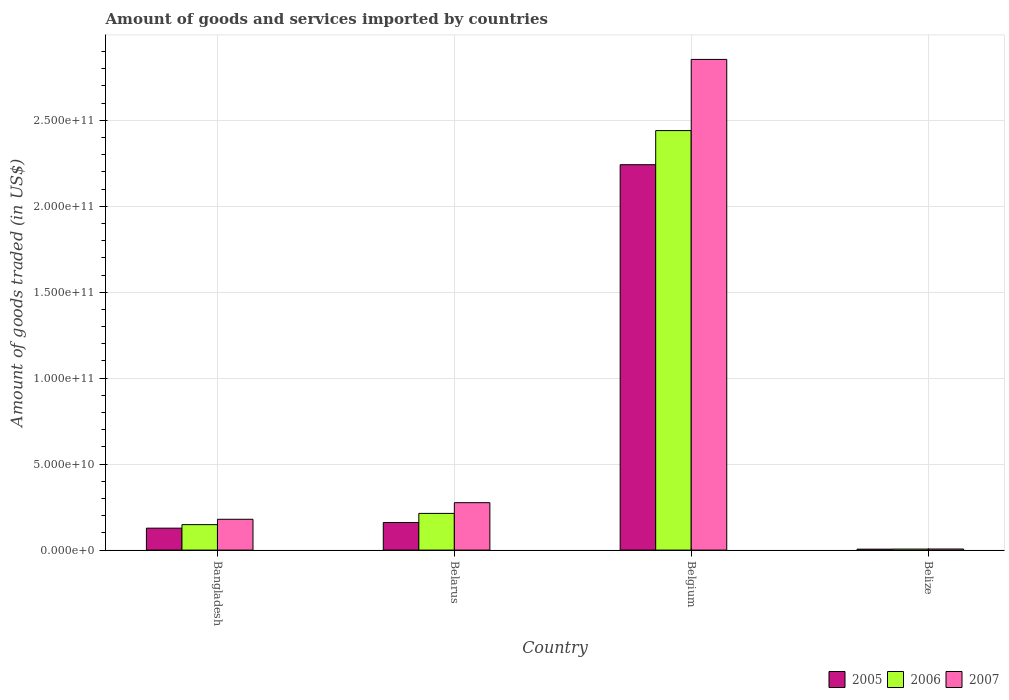How many different coloured bars are there?
Make the answer very short. 3. Are the number of bars per tick equal to the number of legend labels?
Provide a succinct answer. Yes. Are the number of bars on each tick of the X-axis equal?
Ensure brevity in your answer.  Yes. What is the label of the 4th group of bars from the left?
Your response must be concise. Belize. In how many cases, is the number of bars for a given country not equal to the number of legend labels?
Offer a very short reply. 0. What is the total amount of goods and services imported in 2006 in Bangladesh?
Make the answer very short. 1.48e+1. Across all countries, what is the maximum total amount of goods and services imported in 2007?
Your response must be concise. 2.85e+11. Across all countries, what is the minimum total amount of goods and services imported in 2007?
Keep it short and to the point. 6.35e+08. In which country was the total amount of goods and services imported in 2006 maximum?
Your response must be concise. Belgium. In which country was the total amount of goods and services imported in 2006 minimum?
Provide a succinct answer. Belize. What is the total total amount of goods and services imported in 2006 in the graph?
Give a very brief answer. 2.81e+11. What is the difference between the total amount of goods and services imported in 2005 in Bangladesh and that in Belize?
Your response must be concise. 1.22e+1. What is the difference between the total amount of goods and services imported in 2006 in Bangladesh and the total amount of goods and services imported in 2005 in Belarus?
Make the answer very short. -1.24e+09. What is the average total amount of goods and services imported in 2006 per country?
Provide a succinct answer. 7.02e+1. What is the difference between the total amount of goods and services imported of/in 2007 and total amount of goods and services imported of/in 2006 in Bangladesh?
Ensure brevity in your answer.  3.11e+09. What is the ratio of the total amount of goods and services imported in 2007 in Belarus to that in Belize?
Offer a very short reply. 43.46. Is the total amount of goods and services imported in 2005 in Bangladesh less than that in Belize?
Offer a very short reply. No. What is the difference between the highest and the second highest total amount of goods and services imported in 2006?
Your response must be concise. 2.23e+11. What is the difference between the highest and the lowest total amount of goods and services imported in 2006?
Provide a short and direct response. 2.43e+11. In how many countries, is the total amount of goods and services imported in 2007 greater than the average total amount of goods and services imported in 2007 taken over all countries?
Offer a very short reply. 1. What does the 2nd bar from the left in Belarus represents?
Provide a succinct answer. 2006. How many bars are there?
Your answer should be compact. 12. Does the graph contain any zero values?
Your answer should be compact. No. How are the legend labels stacked?
Provide a succinct answer. Horizontal. What is the title of the graph?
Your answer should be very brief. Amount of goods and services imported by countries. What is the label or title of the X-axis?
Provide a short and direct response. Country. What is the label or title of the Y-axis?
Your answer should be compact. Amount of goods traded (in US$). What is the Amount of goods traded (in US$) in 2005 in Bangladesh?
Your response must be concise. 1.28e+1. What is the Amount of goods traded (in US$) of 2006 in Bangladesh?
Provide a short and direct response. 1.48e+1. What is the Amount of goods traded (in US$) of 2007 in Bangladesh?
Offer a very short reply. 1.79e+1. What is the Amount of goods traded (in US$) of 2005 in Belarus?
Your answer should be compact. 1.61e+1. What is the Amount of goods traded (in US$) in 2006 in Belarus?
Ensure brevity in your answer.  2.14e+1. What is the Amount of goods traded (in US$) in 2007 in Belarus?
Provide a short and direct response. 2.76e+1. What is the Amount of goods traded (in US$) of 2005 in Belgium?
Your response must be concise. 2.24e+11. What is the Amount of goods traded (in US$) of 2006 in Belgium?
Provide a succinct answer. 2.44e+11. What is the Amount of goods traded (in US$) of 2007 in Belgium?
Ensure brevity in your answer.  2.85e+11. What is the Amount of goods traded (in US$) in 2005 in Belize?
Offer a terse response. 5.44e+08. What is the Amount of goods traded (in US$) in 2006 in Belize?
Provide a short and direct response. 5.98e+08. What is the Amount of goods traded (in US$) of 2007 in Belize?
Ensure brevity in your answer.  6.35e+08. Across all countries, what is the maximum Amount of goods traded (in US$) of 2005?
Keep it short and to the point. 2.24e+11. Across all countries, what is the maximum Amount of goods traded (in US$) in 2006?
Make the answer very short. 2.44e+11. Across all countries, what is the maximum Amount of goods traded (in US$) of 2007?
Make the answer very short. 2.85e+11. Across all countries, what is the minimum Amount of goods traded (in US$) in 2005?
Give a very brief answer. 5.44e+08. Across all countries, what is the minimum Amount of goods traded (in US$) in 2006?
Provide a succinct answer. 5.98e+08. Across all countries, what is the minimum Amount of goods traded (in US$) of 2007?
Ensure brevity in your answer.  6.35e+08. What is the total Amount of goods traded (in US$) of 2005 in the graph?
Offer a very short reply. 2.54e+11. What is the total Amount of goods traded (in US$) in 2006 in the graph?
Give a very brief answer. 2.81e+11. What is the total Amount of goods traded (in US$) of 2007 in the graph?
Ensure brevity in your answer.  3.32e+11. What is the difference between the Amount of goods traded (in US$) in 2005 in Bangladesh and that in Belarus?
Provide a succinct answer. -3.30e+09. What is the difference between the Amount of goods traded (in US$) in 2006 in Bangladesh and that in Belarus?
Offer a terse response. -6.54e+09. What is the difference between the Amount of goods traded (in US$) of 2007 in Bangladesh and that in Belarus?
Your answer should be very brief. -9.66e+09. What is the difference between the Amount of goods traded (in US$) in 2005 in Bangladesh and that in Belgium?
Your answer should be compact. -2.11e+11. What is the difference between the Amount of goods traded (in US$) of 2006 in Bangladesh and that in Belgium?
Ensure brevity in your answer.  -2.29e+11. What is the difference between the Amount of goods traded (in US$) of 2007 in Bangladesh and that in Belgium?
Your response must be concise. -2.67e+11. What is the difference between the Amount of goods traded (in US$) in 2005 in Bangladesh and that in Belize?
Make the answer very short. 1.22e+1. What is the difference between the Amount of goods traded (in US$) in 2006 in Bangladesh and that in Belize?
Give a very brief answer. 1.42e+1. What is the difference between the Amount of goods traded (in US$) in 2007 in Bangladesh and that in Belize?
Offer a very short reply. 1.73e+1. What is the difference between the Amount of goods traded (in US$) in 2005 in Belarus and that in Belgium?
Your answer should be very brief. -2.08e+11. What is the difference between the Amount of goods traded (in US$) of 2006 in Belarus and that in Belgium?
Provide a short and direct response. -2.23e+11. What is the difference between the Amount of goods traded (in US$) in 2007 in Belarus and that in Belgium?
Provide a succinct answer. -2.58e+11. What is the difference between the Amount of goods traded (in US$) in 2005 in Belarus and that in Belize?
Provide a short and direct response. 1.55e+1. What is the difference between the Amount of goods traded (in US$) in 2006 in Belarus and that in Belize?
Offer a very short reply. 2.08e+1. What is the difference between the Amount of goods traded (in US$) of 2007 in Belarus and that in Belize?
Provide a short and direct response. 2.69e+1. What is the difference between the Amount of goods traded (in US$) in 2005 in Belgium and that in Belize?
Make the answer very short. 2.24e+11. What is the difference between the Amount of goods traded (in US$) in 2006 in Belgium and that in Belize?
Offer a terse response. 2.43e+11. What is the difference between the Amount of goods traded (in US$) of 2007 in Belgium and that in Belize?
Make the answer very short. 2.85e+11. What is the difference between the Amount of goods traded (in US$) of 2005 in Bangladesh and the Amount of goods traded (in US$) of 2006 in Belarus?
Ensure brevity in your answer.  -8.59e+09. What is the difference between the Amount of goods traded (in US$) of 2005 in Bangladesh and the Amount of goods traded (in US$) of 2007 in Belarus?
Keep it short and to the point. -1.48e+1. What is the difference between the Amount of goods traded (in US$) of 2006 in Bangladesh and the Amount of goods traded (in US$) of 2007 in Belarus?
Give a very brief answer. -1.28e+1. What is the difference between the Amount of goods traded (in US$) of 2005 in Bangladesh and the Amount of goods traded (in US$) of 2006 in Belgium?
Offer a very short reply. -2.31e+11. What is the difference between the Amount of goods traded (in US$) of 2005 in Bangladesh and the Amount of goods traded (in US$) of 2007 in Belgium?
Make the answer very short. -2.73e+11. What is the difference between the Amount of goods traded (in US$) of 2006 in Bangladesh and the Amount of goods traded (in US$) of 2007 in Belgium?
Offer a very short reply. -2.71e+11. What is the difference between the Amount of goods traded (in US$) in 2005 in Bangladesh and the Amount of goods traded (in US$) in 2006 in Belize?
Ensure brevity in your answer.  1.22e+1. What is the difference between the Amount of goods traded (in US$) of 2005 in Bangladesh and the Amount of goods traded (in US$) of 2007 in Belize?
Your response must be concise. 1.21e+1. What is the difference between the Amount of goods traded (in US$) of 2006 in Bangladesh and the Amount of goods traded (in US$) of 2007 in Belize?
Provide a succinct answer. 1.42e+1. What is the difference between the Amount of goods traded (in US$) in 2005 in Belarus and the Amount of goods traded (in US$) in 2006 in Belgium?
Provide a succinct answer. -2.28e+11. What is the difference between the Amount of goods traded (in US$) of 2005 in Belarus and the Amount of goods traded (in US$) of 2007 in Belgium?
Make the answer very short. -2.69e+11. What is the difference between the Amount of goods traded (in US$) of 2006 in Belarus and the Amount of goods traded (in US$) of 2007 in Belgium?
Provide a short and direct response. -2.64e+11. What is the difference between the Amount of goods traded (in US$) of 2005 in Belarus and the Amount of goods traded (in US$) of 2006 in Belize?
Your response must be concise. 1.55e+1. What is the difference between the Amount of goods traded (in US$) in 2005 in Belarus and the Amount of goods traded (in US$) in 2007 in Belize?
Your answer should be very brief. 1.54e+1. What is the difference between the Amount of goods traded (in US$) in 2006 in Belarus and the Amount of goods traded (in US$) in 2007 in Belize?
Provide a succinct answer. 2.07e+1. What is the difference between the Amount of goods traded (in US$) in 2005 in Belgium and the Amount of goods traded (in US$) in 2006 in Belize?
Your response must be concise. 2.24e+11. What is the difference between the Amount of goods traded (in US$) in 2005 in Belgium and the Amount of goods traded (in US$) in 2007 in Belize?
Provide a succinct answer. 2.24e+11. What is the difference between the Amount of goods traded (in US$) of 2006 in Belgium and the Amount of goods traded (in US$) of 2007 in Belize?
Provide a succinct answer. 2.43e+11. What is the average Amount of goods traded (in US$) of 2005 per country?
Provide a short and direct response. 6.34e+1. What is the average Amount of goods traded (in US$) of 2006 per country?
Provide a short and direct response. 7.02e+1. What is the average Amount of goods traded (in US$) of 2007 per country?
Your answer should be compact. 8.29e+1. What is the difference between the Amount of goods traded (in US$) of 2005 and Amount of goods traded (in US$) of 2006 in Bangladesh?
Keep it short and to the point. -2.06e+09. What is the difference between the Amount of goods traded (in US$) in 2005 and Amount of goods traded (in US$) in 2007 in Bangladesh?
Your response must be concise. -5.17e+09. What is the difference between the Amount of goods traded (in US$) of 2006 and Amount of goods traded (in US$) of 2007 in Bangladesh?
Your answer should be compact. -3.11e+09. What is the difference between the Amount of goods traded (in US$) of 2005 and Amount of goods traded (in US$) of 2006 in Belarus?
Your response must be concise. -5.30e+09. What is the difference between the Amount of goods traded (in US$) of 2005 and Amount of goods traded (in US$) of 2007 in Belarus?
Offer a very short reply. -1.15e+1. What is the difference between the Amount of goods traded (in US$) of 2006 and Amount of goods traded (in US$) of 2007 in Belarus?
Provide a short and direct response. -6.23e+09. What is the difference between the Amount of goods traded (in US$) in 2005 and Amount of goods traded (in US$) in 2006 in Belgium?
Give a very brief answer. -1.98e+1. What is the difference between the Amount of goods traded (in US$) of 2005 and Amount of goods traded (in US$) of 2007 in Belgium?
Make the answer very short. -6.12e+1. What is the difference between the Amount of goods traded (in US$) in 2006 and Amount of goods traded (in US$) in 2007 in Belgium?
Make the answer very short. -4.14e+1. What is the difference between the Amount of goods traded (in US$) of 2005 and Amount of goods traded (in US$) of 2006 in Belize?
Your response must be concise. -5.37e+07. What is the difference between the Amount of goods traded (in US$) in 2005 and Amount of goods traded (in US$) in 2007 in Belize?
Provide a short and direct response. -9.05e+07. What is the difference between the Amount of goods traded (in US$) in 2006 and Amount of goods traded (in US$) in 2007 in Belize?
Provide a short and direct response. -3.68e+07. What is the ratio of the Amount of goods traded (in US$) in 2005 in Bangladesh to that in Belarus?
Give a very brief answer. 0.79. What is the ratio of the Amount of goods traded (in US$) in 2006 in Bangladesh to that in Belarus?
Your response must be concise. 0.69. What is the ratio of the Amount of goods traded (in US$) of 2007 in Bangladesh to that in Belarus?
Offer a very short reply. 0.65. What is the ratio of the Amount of goods traded (in US$) of 2005 in Bangladesh to that in Belgium?
Make the answer very short. 0.06. What is the ratio of the Amount of goods traded (in US$) of 2006 in Bangladesh to that in Belgium?
Offer a very short reply. 0.06. What is the ratio of the Amount of goods traded (in US$) in 2007 in Bangladesh to that in Belgium?
Ensure brevity in your answer.  0.06. What is the ratio of the Amount of goods traded (in US$) of 2005 in Bangladesh to that in Belize?
Make the answer very short. 23.44. What is the ratio of the Amount of goods traded (in US$) of 2006 in Bangladesh to that in Belize?
Provide a succinct answer. 24.78. What is the ratio of the Amount of goods traded (in US$) in 2007 in Bangladesh to that in Belize?
Your answer should be compact. 28.24. What is the ratio of the Amount of goods traded (in US$) of 2005 in Belarus to that in Belgium?
Provide a succinct answer. 0.07. What is the ratio of the Amount of goods traded (in US$) in 2006 in Belarus to that in Belgium?
Offer a terse response. 0.09. What is the ratio of the Amount of goods traded (in US$) of 2007 in Belarus to that in Belgium?
Keep it short and to the point. 0.1. What is the ratio of the Amount of goods traded (in US$) in 2005 in Belarus to that in Belize?
Your answer should be compact. 29.5. What is the ratio of the Amount of goods traded (in US$) of 2006 in Belarus to that in Belize?
Offer a very short reply. 35.71. What is the ratio of the Amount of goods traded (in US$) of 2007 in Belarus to that in Belize?
Ensure brevity in your answer.  43.46. What is the ratio of the Amount of goods traded (in US$) of 2005 in Belgium to that in Belize?
Your answer should be very brief. 411.92. What is the ratio of the Amount of goods traded (in US$) in 2006 in Belgium to that in Belize?
Provide a succinct answer. 408.14. What is the ratio of the Amount of goods traded (in US$) in 2007 in Belgium to that in Belize?
Keep it short and to the point. 449.67. What is the difference between the highest and the second highest Amount of goods traded (in US$) of 2005?
Offer a very short reply. 2.08e+11. What is the difference between the highest and the second highest Amount of goods traded (in US$) of 2006?
Your answer should be compact. 2.23e+11. What is the difference between the highest and the second highest Amount of goods traded (in US$) in 2007?
Your answer should be very brief. 2.58e+11. What is the difference between the highest and the lowest Amount of goods traded (in US$) of 2005?
Offer a terse response. 2.24e+11. What is the difference between the highest and the lowest Amount of goods traded (in US$) of 2006?
Your answer should be compact. 2.43e+11. What is the difference between the highest and the lowest Amount of goods traded (in US$) of 2007?
Your answer should be very brief. 2.85e+11. 